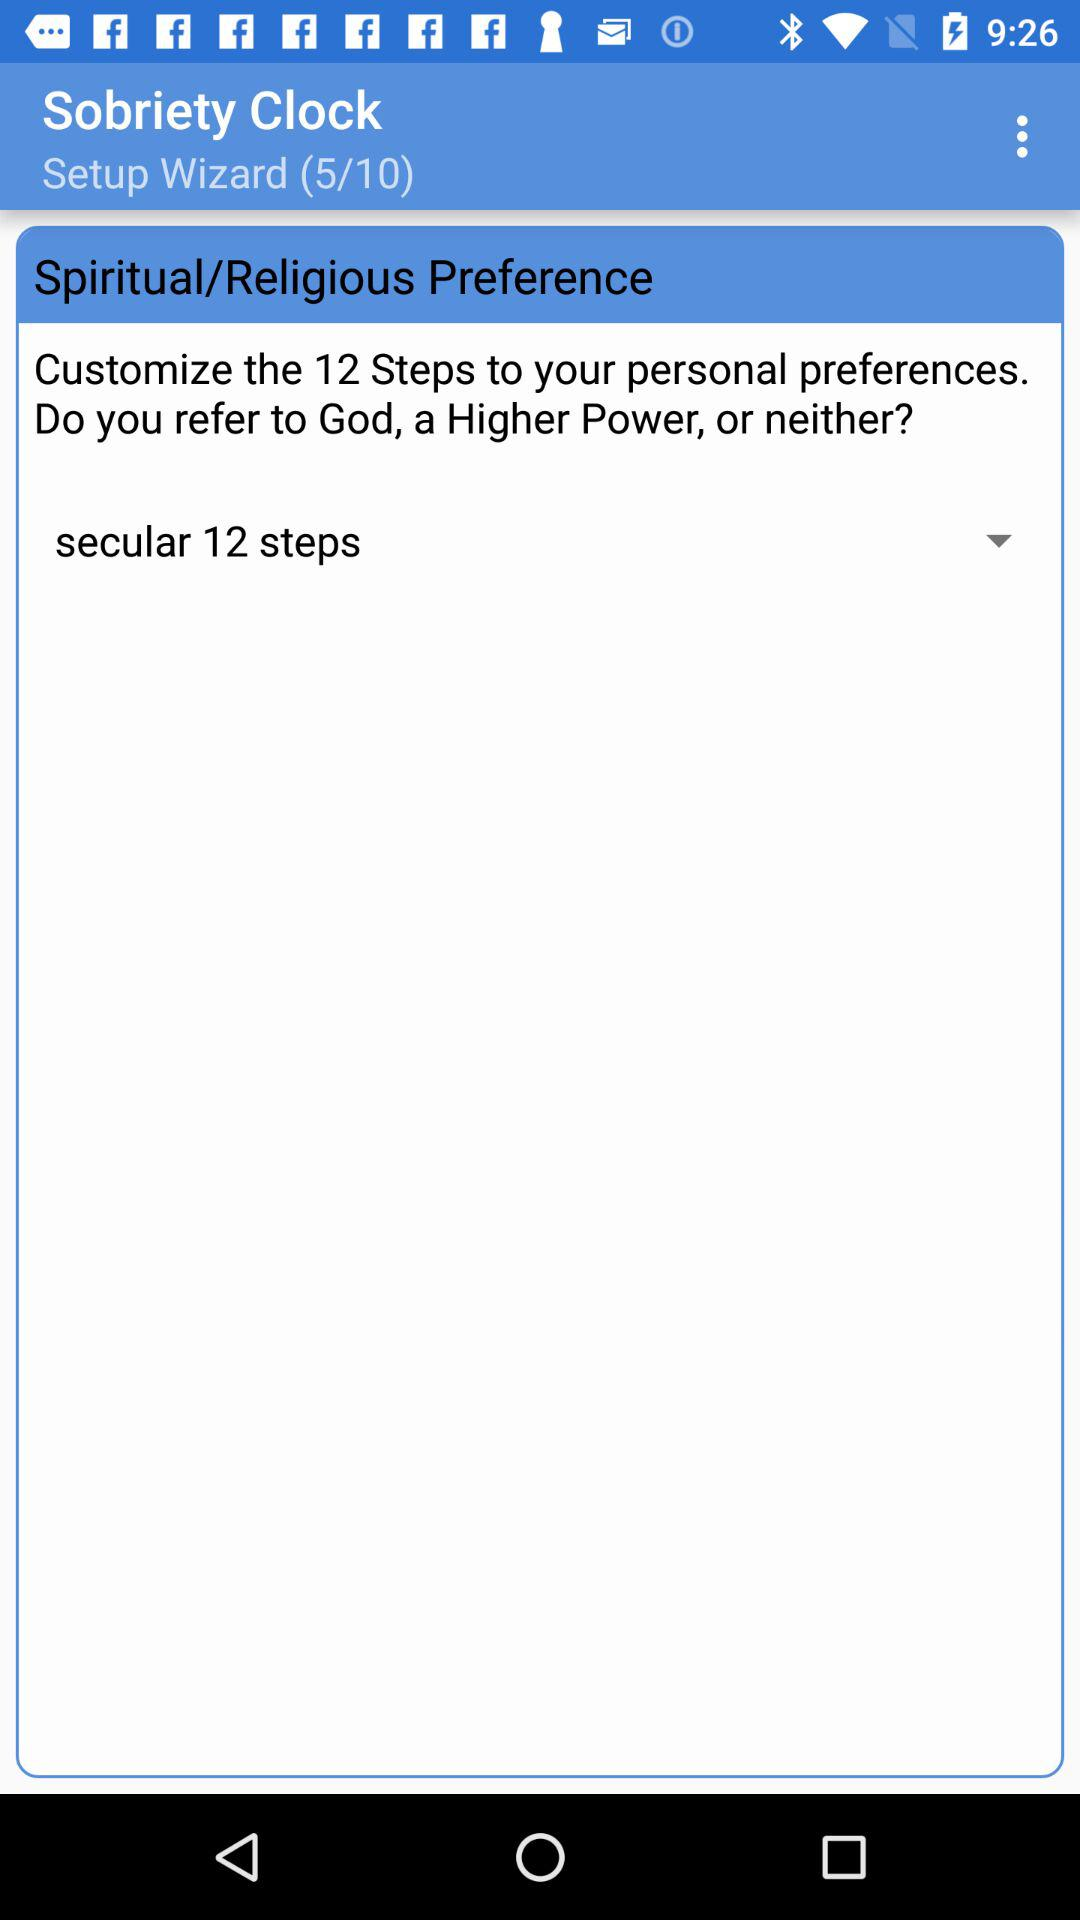What are the total number of "Setup Wizard"? The total number of "Setup Wizard" is 10. 